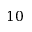Convert formula to latex. <formula><loc_0><loc_0><loc_500><loc_500>1 0</formula> 